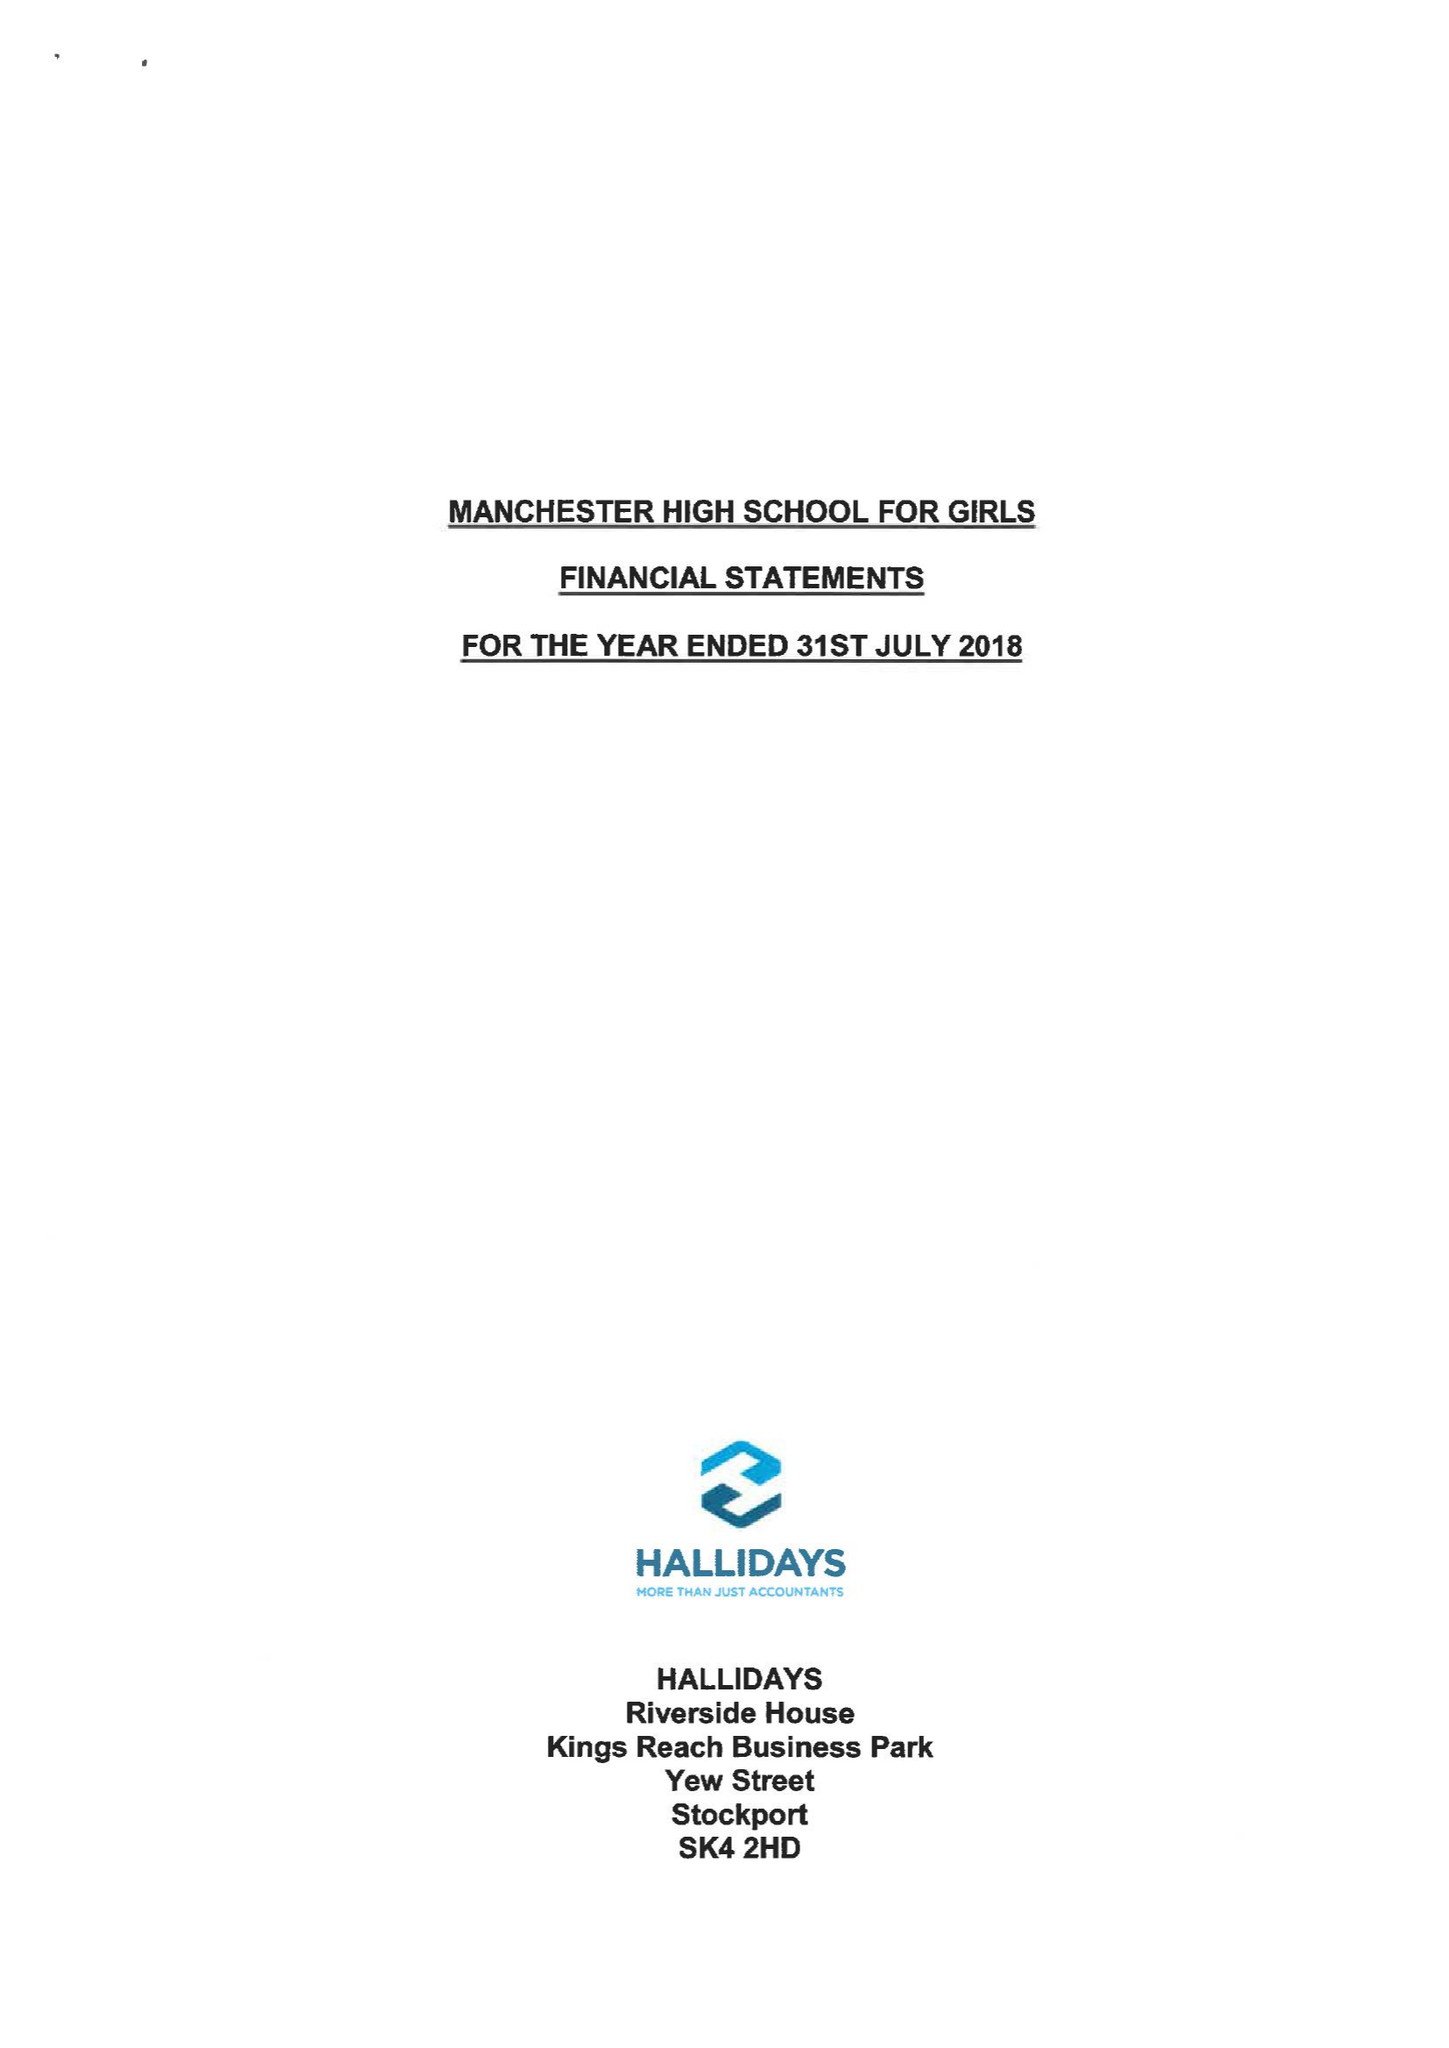What is the value for the income_annually_in_british_pounds?
Answer the question using a single word or phrase. 10462345.00 